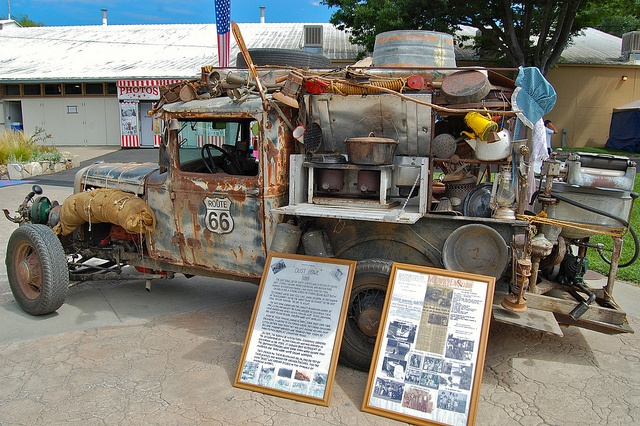Describe the objects in this image and their specific colors. I can see truck in lightblue, black, gray, and darkgray tones and people in lightblue, darkgray, black, and gray tones in this image. 